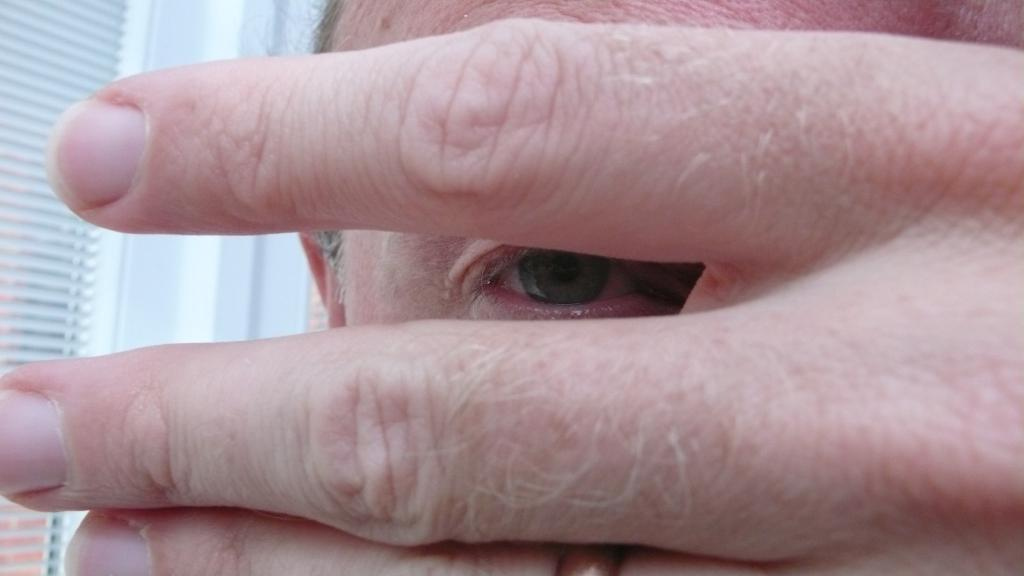What part of the body is visible in the image? There is a person's eye visible in the image. What else can be seen in the image besides the eye? There are fingers visible in the image. What type of structure is present in the image? There is a wall in the image. Is there any opening in the wall visible in the image? Yes, there is a window in the image. What type of powder is being used to clean the camera in the image? There is no camera or powder present in the image. How many houses are visible in the image? There are no houses visible in the image. 